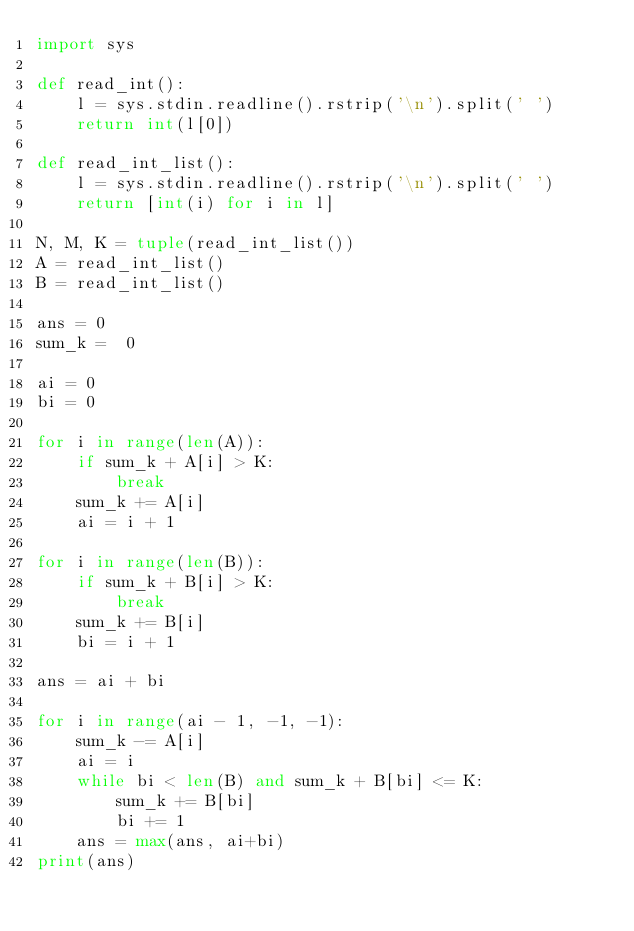Convert code to text. <code><loc_0><loc_0><loc_500><loc_500><_Python_>import sys

def read_int():
    l = sys.stdin.readline().rstrip('\n').split(' ')
    return int(l[0])

def read_int_list():
    l = sys.stdin.readline().rstrip('\n').split(' ')
    return [int(i) for i in l]

N, M, K = tuple(read_int_list())
A = read_int_list()
B = read_int_list()

ans = 0
sum_k =  0

ai = 0
bi = 0

for i in range(len(A)):
    if sum_k + A[i] > K:
        break
    sum_k += A[i]
    ai = i + 1

for i in range(len(B)):
    if sum_k + B[i] > K:
        break
    sum_k += B[i]
    bi = i + 1

ans = ai + bi

for i in range(ai - 1, -1, -1):
    sum_k -= A[i]
    ai = i
    while bi < len(B) and sum_k + B[bi] <= K:
        sum_k += B[bi]
        bi += 1
    ans = max(ans, ai+bi)
print(ans)

</code> 